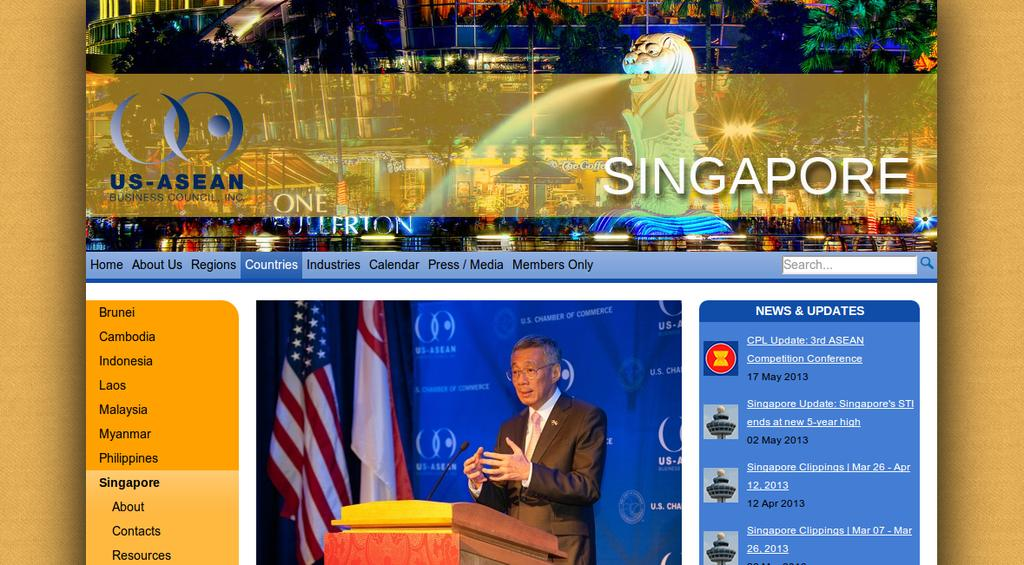<image>
Summarize the visual content of the image. The US-ASEAN website with a man at a podium based in Singapore. 